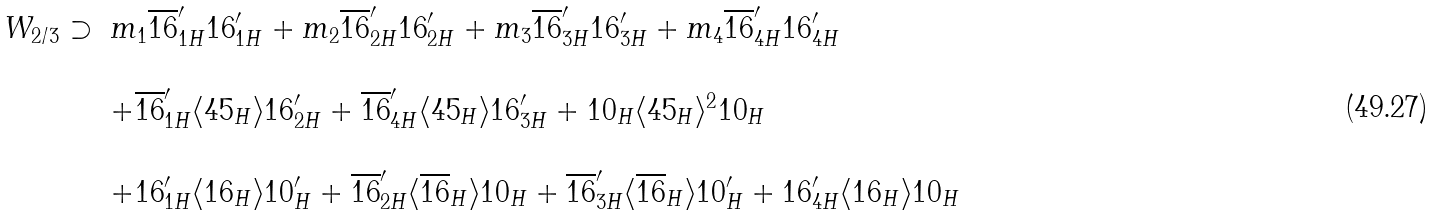<formula> <loc_0><loc_0><loc_500><loc_500>\begin{array} { c l } W _ { 2 / 3 } \supset & m _ { 1 } \overline { 1 6 } ^ { \prime } _ { 1 H } { 1 6 } ^ { \prime } _ { 1 H } + m _ { 2 } \overline { 1 6 } ^ { \prime } _ { 2 H } { 1 6 } ^ { \prime } _ { 2 H } + m _ { 3 } \overline { 1 6 } ^ { \prime } _ { 3 H } { 1 6 } ^ { \prime } _ { 3 H } + m _ { 4 } \overline { 1 6 } ^ { \prime } _ { 4 H } { 1 6 } ^ { \prime } _ { 4 H } \\ \\ & + \overline { 1 6 } ^ { \prime } _ { 1 H } \langle { 4 5 } _ { H } \rangle { 1 6 } ^ { \prime } _ { 2 H } + \overline { 1 6 } ^ { \prime } _ { 4 H } \langle { 4 5 } _ { H } \rangle { 1 6 } ^ { \prime } _ { 3 H } + { 1 0 } _ { H } \langle { 4 5 } _ { H } \rangle ^ { 2 } { 1 0 } _ { H } \\ \\ & + { 1 6 } ^ { \prime } _ { 1 H } \langle { 1 6 } _ { H } \rangle { 1 0 } ^ { \prime } _ { H } + \overline { 1 6 } ^ { \prime } _ { 2 H } \langle \overline { 1 6 } _ { H } \rangle { 1 0 } _ { H } + \overline { 1 6 } ^ { \prime } _ { 3 H } \langle \overline { 1 6 } _ { H } \rangle { 1 0 } ^ { \prime } _ { H } + { 1 6 } ^ { \prime } _ { 4 H } \langle { 1 6 } _ { H } \rangle { 1 0 } _ { H } \end{array}</formula> 